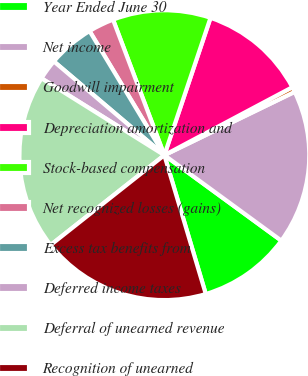<chart> <loc_0><loc_0><loc_500><loc_500><pie_chart><fcel>Year Ended June 30<fcel>Net income<fcel>Goodwill impairment<fcel>Depreciation amortization and<fcel>Stock-based compensation<fcel>Net recognized losses (gains)<fcel>Excess tax benefits from<fcel>Deferred income taxes<fcel>Deferral of unearned revenue<fcel>Recognition of unearned<nl><fcel>10.34%<fcel>17.24%<fcel>0.57%<fcel>12.07%<fcel>10.92%<fcel>2.87%<fcel>5.17%<fcel>2.3%<fcel>19.54%<fcel>18.97%<nl></chart> 